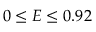Convert formula to latex. <formula><loc_0><loc_0><loc_500><loc_500>0 \leq E \leq 0 . 9 2</formula> 